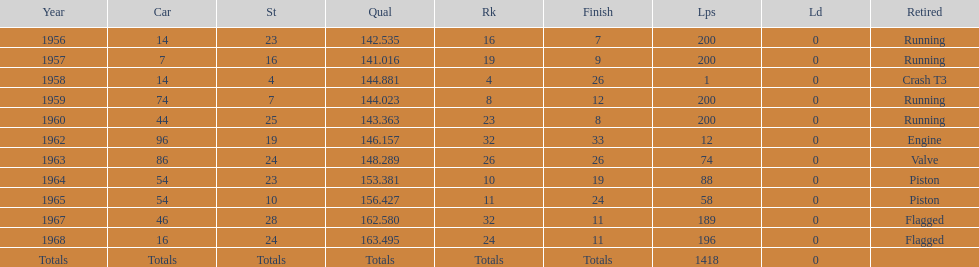In which year does the final qual appear on the chart? 1968. 